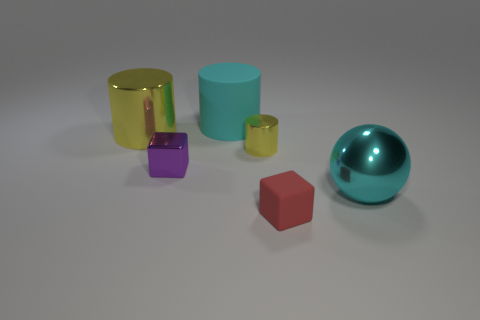Subtract all tiny cylinders. How many cylinders are left? 2 Subtract all yellow blocks. How many yellow cylinders are left? 2 Subtract 1 cylinders. How many cylinders are left? 2 Add 3 cyan metal objects. How many objects exist? 9 Subtract all spheres. How many objects are left? 5 Subtract all red cylinders. Subtract all red spheres. How many cylinders are left? 3 Add 3 metallic cylinders. How many metallic cylinders are left? 5 Add 4 large objects. How many large objects exist? 7 Subtract 0 red cylinders. How many objects are left? 6 Subtract all rubber cubes. Subtract all yellow things. How many objects are left? 3 